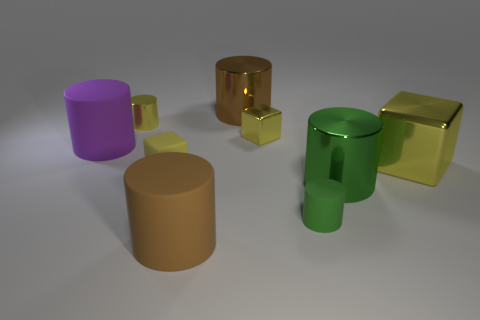What number of blocks are either tiny things or yellow things?
Offer a terse response. 3. Is there anything else that has the same material as the big purple thing?
Provide a short and direct response. Yes. There is a large thing behind the tiny cylinder that is on the left side of the big brown thing that is behind the tiny green thing; what is it made of?
Provide a short and direct response. Metal. There is another large block that is the same color as the matte cube; what material is it?
Provide a short and direct response. Metal. How many small green cylinders are made of the same material as the tiny yellow cylinder?
Your answer should be compact. 0. Is the size of the yellow metallic block that is in front of the purple object the same as the small yellow matte cube?
Your response must be concise. No. There is a tiny block that is the same material as the large purple object; what is its color?
Make the answer very short. Yellow. There is a tiny green matte object; how many matte cylinders are in front of it?
Keep it short and to the point. 1. There is a shiny block that is behind the purple object; does it have the same color as the large matte object that is to the left of the brown matte cylinder?
Provide a short and direct response. No. There is a small metal object that is the same shape as the brown matte thing; what color is it?
Make the answer very short. Yellow. 